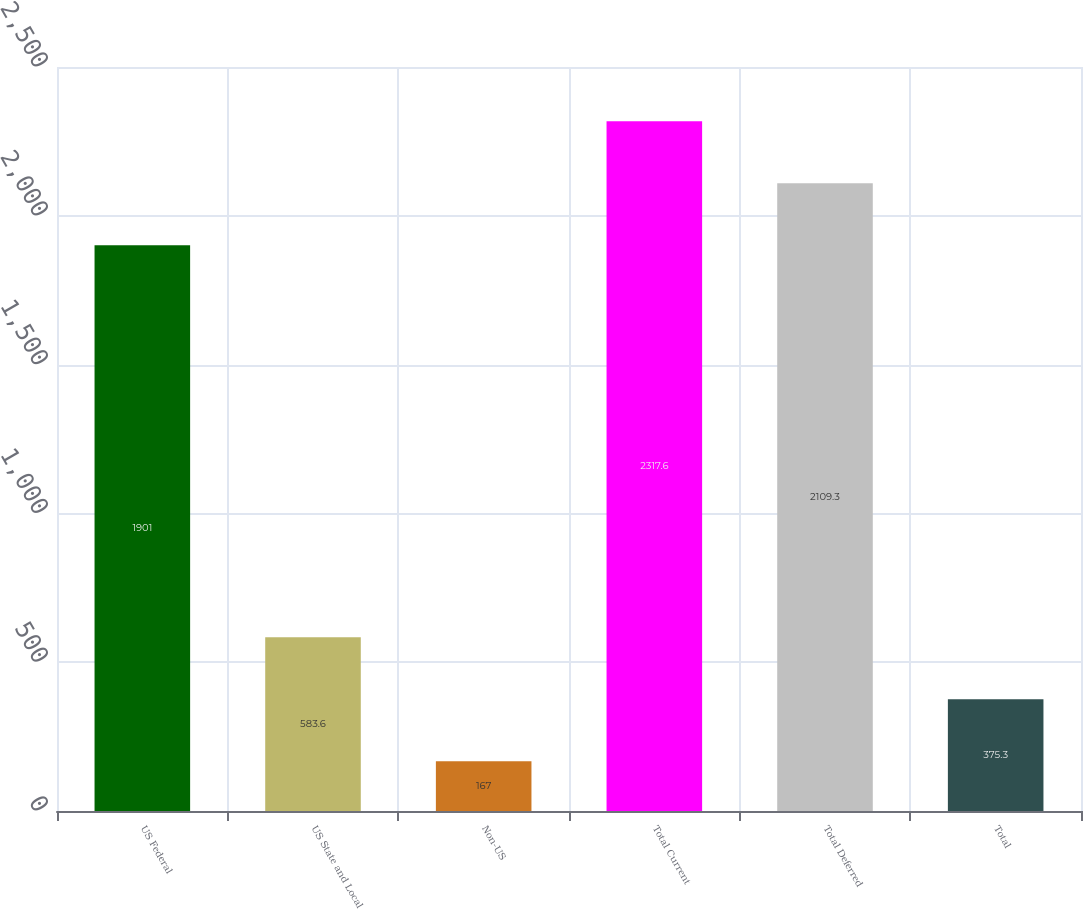Convert chart. <chart><loc_0><loc_0><loc_500><loc_500><bar_chart><fcel>US Federal<fcel>US State and Local<fcel>Non-US<fcel>Total Current<fcel>Total Deferred<fcel>Total<nl><fcel>1901<fcel>583.6<fcel>167<fcel>2317.6<fcel>2109.3<fcel>375.3<nl></chart> 